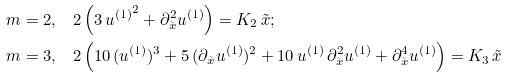<formula> <loc_0><loc_0><loc_500><loc_500>m = 2 , & \quad 2 \left ( 3 \, { u ^ { ( 1 ) } } ^ { 2 } + \partial _ { \tilde { x } } ^ { 2 } u ^ { ( 1 ) } \right ) = K _ { 2 } \, \tilde { x } ; \\ m = 3 , & \quad 2 \left ( 1 0 \, ( u ^ { ( 1 ) } ) ^ { 3 } + 5 \, ( \partial _ { \tilde { x } } u ^ { ( 1 ) } ) ^ { 2 } + 1 0 \, u ^ { ( 1 ) } \, \partial _ { \tilde { x } } ^ { 2 } u ^ { ( 1 ) } + \partial _ { \tilde { x } } ^ { 4 } u ^ { ( 1 ) } \right ) = K _ { 3 } \, \tilde { x }</formula> 